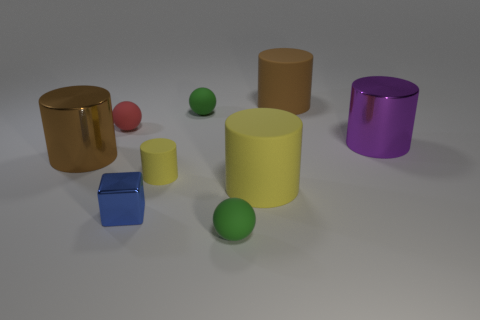Add 1 green rubber spheres. How many objects exist? 10 Subtract all big yellow cylinders. How many cylinders are left? 4 Subtract all green spheres. How many spheres are left? 1 Subtract 5 cylinders. How many cylinders are left? 0 Subtract all yellow cubes. How many yellow cylinders are left? 2 Subtract all purple cylinders. Subtract all tiny green objects. How many objects are left? 6 Add 9 purple things. How many purple things are left? 10 Add 4 small green rubber spheres. How many small green rubber spheres exist? 6 Subtract 1 yellow cylinders. How many objects are left? 8 Subtract all cylinders. How many objects are left? 4 